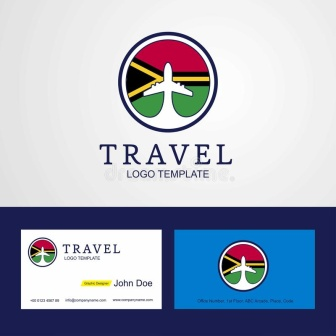Can you explain the choice of colors in the logo? The color scheme in the logo is vibrant and carefully chosen to represent different qualities and emotions, enhancing the travel theme. Red can signify excitement and passion, green suggests safety and tranquility, blue is often associated with trust and reliability, while yellow brings a sense of joy and energy. Together, these colors not only make the logo eye-catching but also convey a broad, positive message about the experiences the company offers. 